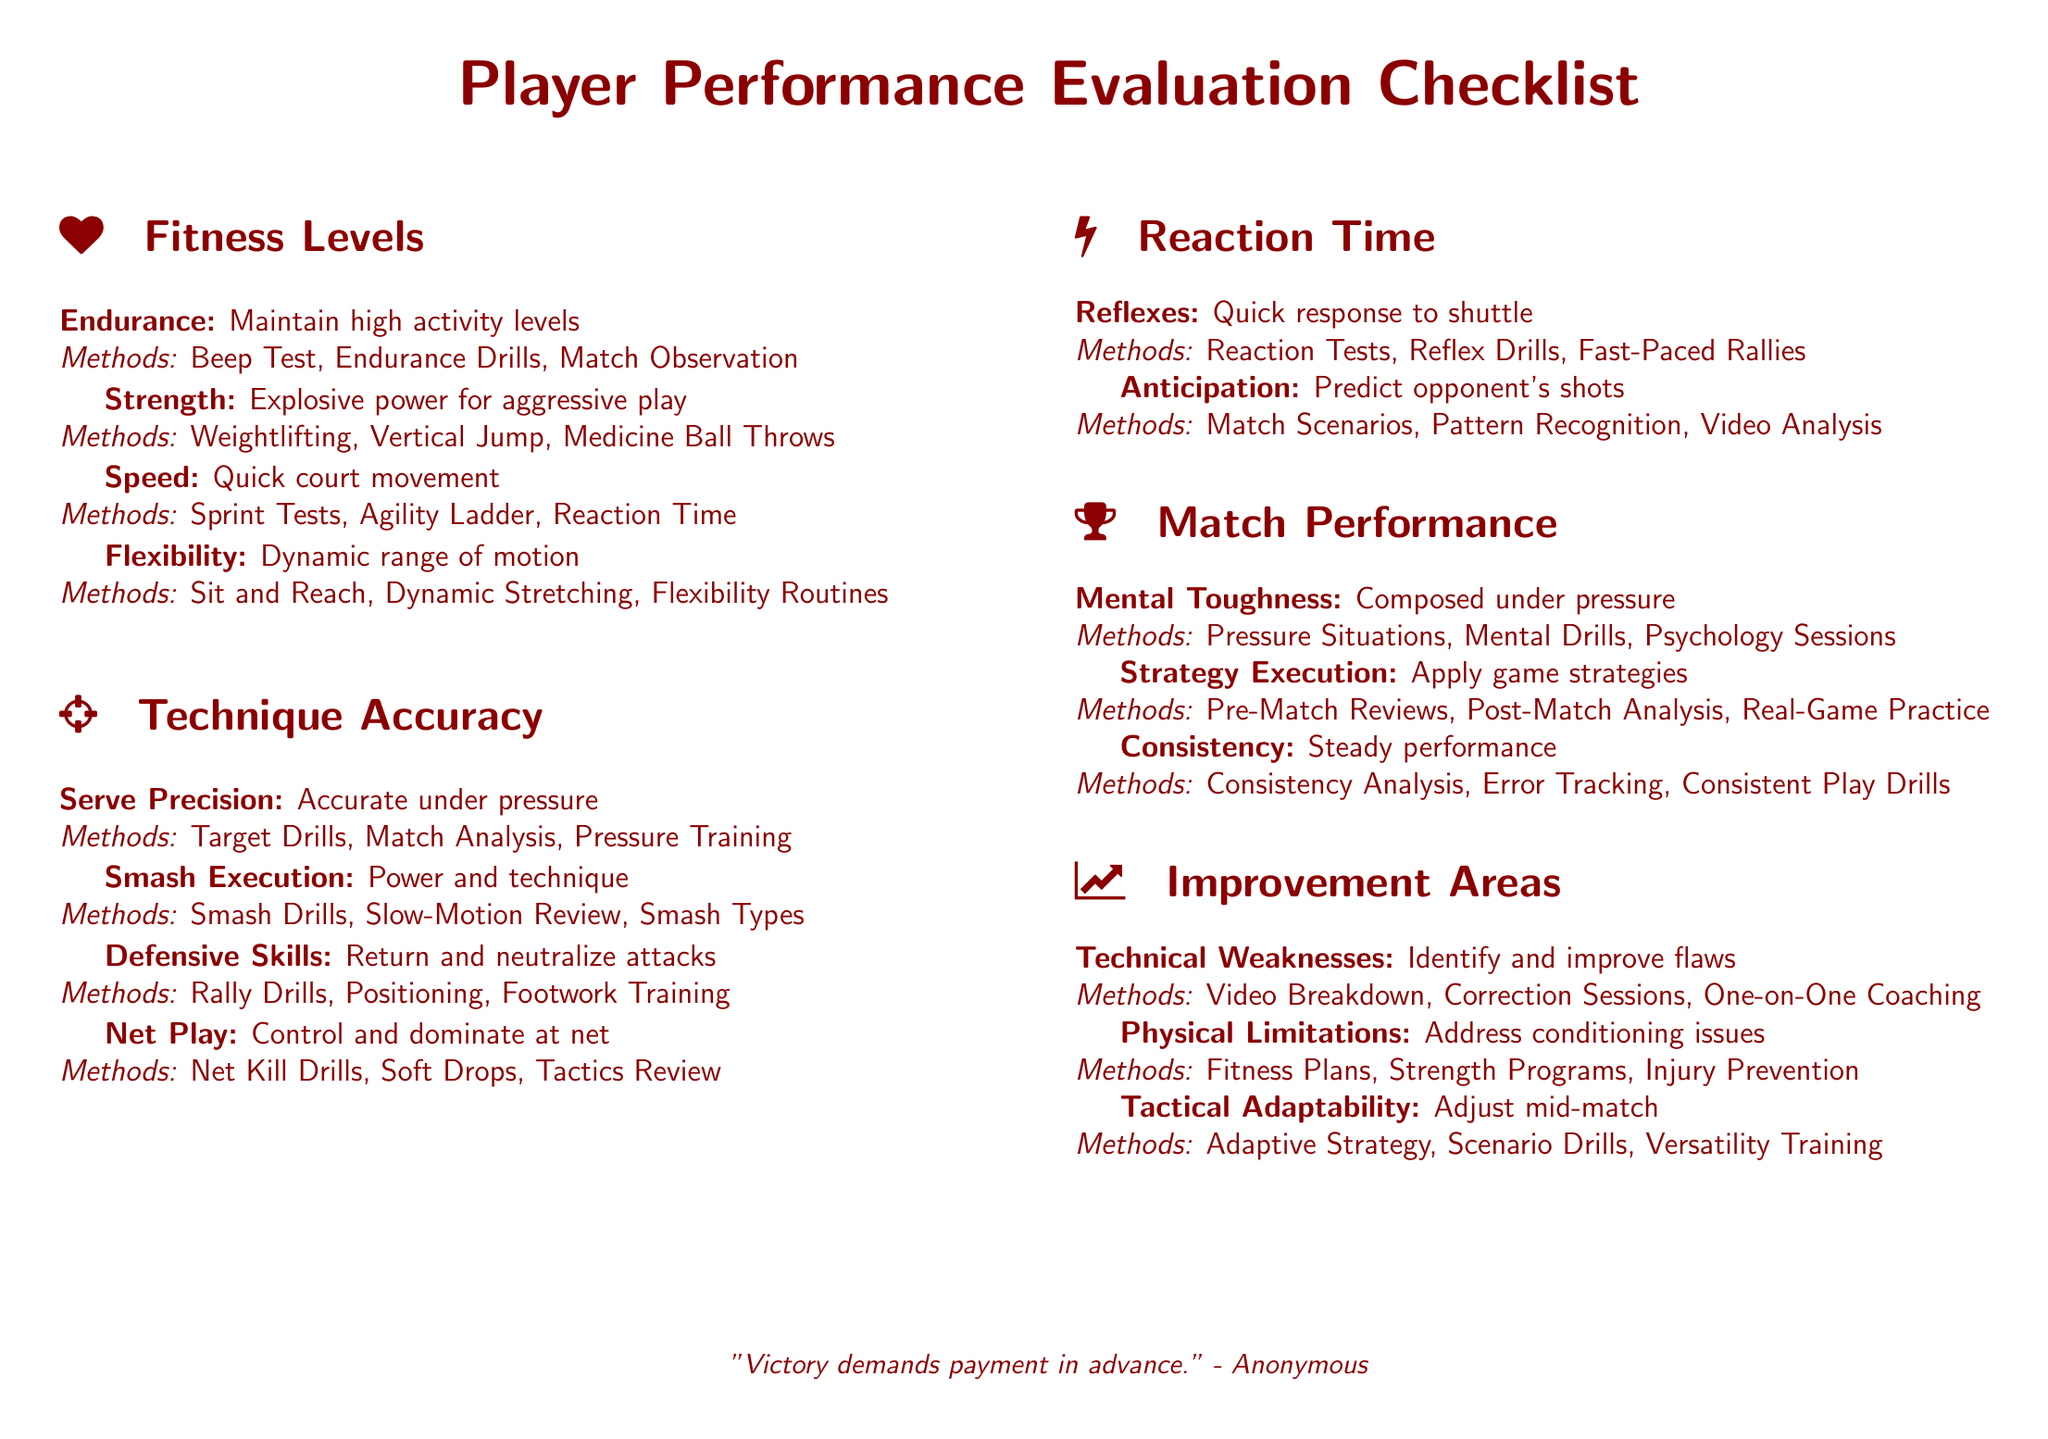What are the criteria for fitness levels? The criteria for fitness levels include Endurance, Strength, Speed, and Flexibility.
Answer: Endurance, Strength, Speed, Flexibility What method is used to assess Serve Precision? The method used to assess Serve Precision includes Target Drills, Match Analysis, and Pressure Training.
Answer: Target Drills, Match Analysis, Pressure Training How many criteria are listed under Match Performance? The document lists three criteria under Match Performance.
Answer: Three What is emphasized for reaction time assessment? Reflexes and anticipation are emphasized for reaction time assessment.
Answer: Reflexes, anticipation Which improvement area addresses conditioning issues? The improvement area that addresses conditioning issues is Physical Limitations.
Answer: Physical Limitations What training methods are mentioned for Tactical Adaptability? The training methods mentioned for Tactical Adaptability include Adaptive Strategy, Scenario Drills, and Versatility Training.
Answer: Adaptive Strategy, Scenario Drills, Versatility Training What is the focus of the Mental Toughness criterion? The focus of the Mental Toughness criterion is being composed under pressure.
Answer: Composed under pressure Which fitness assessment method tests explosive power? The fitness assessment method that tests explosive power is Weightlifting.
Answer: Weightlifting What type of drills are suggested for improving Smash Execution? Smash Drills are suggested for improving Smash Execution.
Answer: Smash Drills 